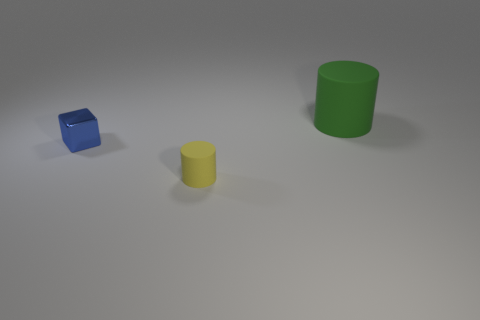Add 3 cubes. How many objects exist? 6 Subtract all cylinders. How many objects are left? 1 Subtract 1 blue blocks. How many objects are left? 2 Subtract all green rubber balls. Subtract all yellow rubber cylinders. How many objects are left? 2 Add 2 small blue metallic cubes. How many small blue metallic cubes are left? 3 Add 2 tiny blocks. How many tiny blocks exist? 3 